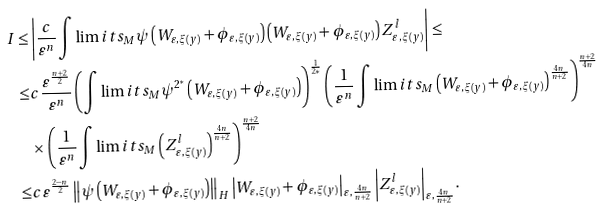<formula> <loc_0><loc_0><loc_500><loc_500>I \leq & \left | \frac { c } { \varepsilon ^ { n } } \int \lim i t s _ { M } \psi \left ( { W _ { \varepsilon , \xi ( y ) } + \phi _ { \varepsilon , \xi ( y ) } } \right ) \left ( { W _ { \varepsilon , \xi ( y ) } + \phi _ { \varepsilon , \xi ( y ) } } \right ) Z _ { \varepsilon , \xi ( y ) } ^ { l } \right | \leq \\ \leq & c \frac { \varepsilon ^ { \frac { n + 2 } { 2 } } } { \varepsilon ^ { n } } \left ( \int \lim i t s _ { M } \psi ^ { 2 ^ { * } } \left ( { W _ { \varepsilon , \xi ( y ) } + \phi _ { \varepsilon , \xi ( y ) } } \right ) \right ) ^ { \frac { 1 } { 2 * } } \left ( \frac { 1 } { \varepsilon ^ { n } } \int \lim i t s _ { M } \left ( { W _ { \varepsilon , \xi ( y ) } + \phi _ { \varepsilon , \xi ( y ) } } \right ) ^ { \frac { 4 n } { n + 2 } } \right ) ^ { \frac { n + 2 } { 4 n } } \\ & \times \left ( \frac { 1 } { \varepsilon ^ { n } } \int \lim i t s _ { M } \left ( Z _ { \varepsilon , \xi ( y ) } ^ { l } \right ) ^ { \frac { 4 n } { n + 2 } } \right ) ^ { \frac { n + 2 } { 4 n } } \\ \leq & c \varepsilon ^ { \frac { 2 - n } { 2 } } \left \| \psi \left ( { W _ { \varepsilon , \xi ( y ) } + \phi _ { \varepsilon , \xi ( y ) } } \right ) \right \| _ { H } \left | W _ { \varepsilon , \xi ( y ) } + \phi _ { \varepsilon , \xi ( y ) } \right | _ { \varepsilon , \frac { 4 n } { n + 2 } } \left | Z _ { \varepsilon , \xi ( y ) } ^ { l } \right | _ { \varepsilon , \frac { 4 n } { n + 2 } } .</formula> 